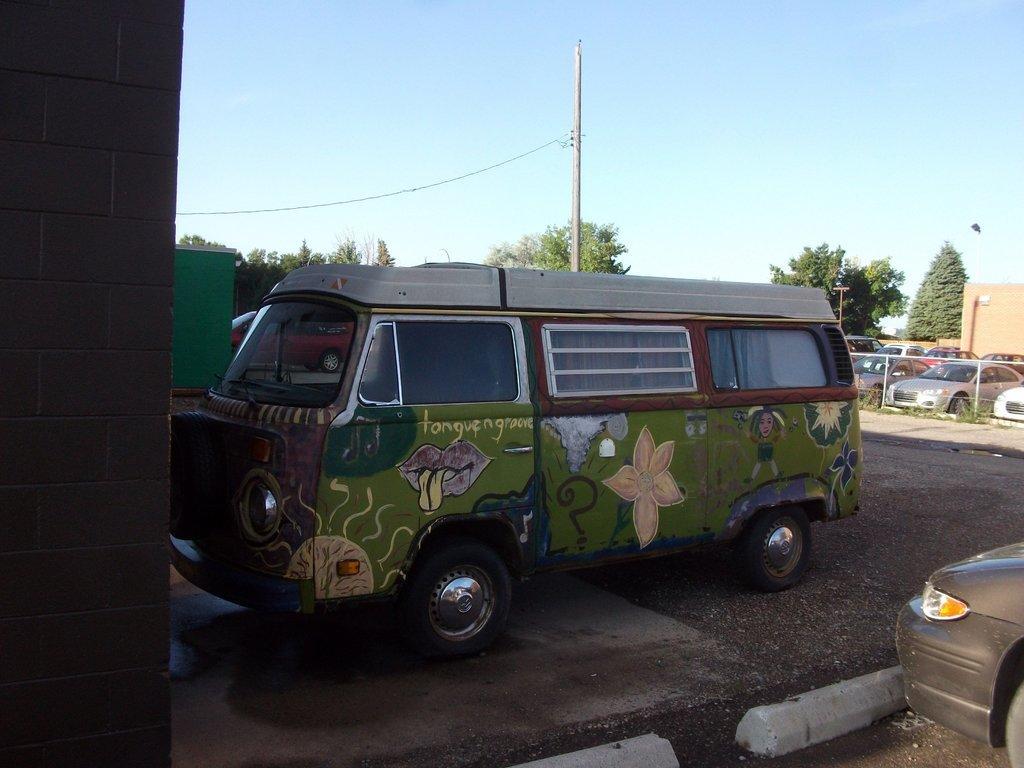How would you summarize this image in a sentence or two? This is an outside view. On the left side there is a pillar. In the middle of the image there is a van on the road. In the background there are many vehicles, trees and also I can see the poles. At the top of the image I can see the sky. 